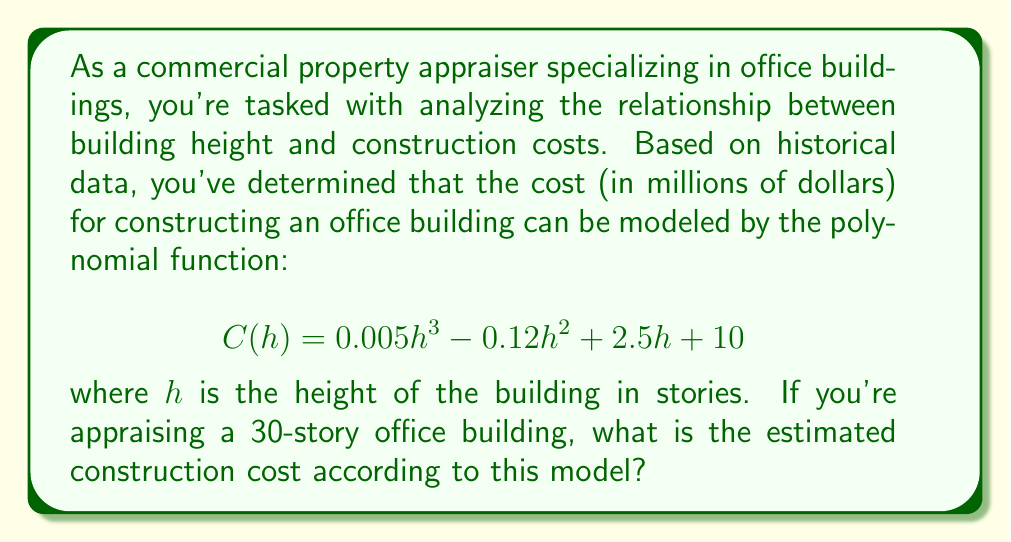Help me with this question. To solve this problem, we need to evaluate the given polynomial function at $h = 30$. Let's break it down step by step:

1) The given function is:
   $$C(h) = 0.005h^3 - 0.12h^2 + 2.5h + 10$$

2) We need to calculate $C(30)$. Let's substitute $h = 30$ into the function:
   $$C(30) = 0.005(30^3) - 0.12(30^2) + 2.5(30) + 10$$

3) Now, let's evaluate each term:
   - $0.005(30^3) = 0.005 * 27000 = 135$
   - $-0.12(30^2) = -0.12 * 900 = -108$
   - $2.5(30) = 75$
   - The constant term is already 10

4) Adding these terms:
   $$C(30) = 135 - 108 + 75 + 10 = 112$$

Therefore, according to this model, the estimated construction cost for a 30-story office building is 112 million dollars.
Answer: $112 million 